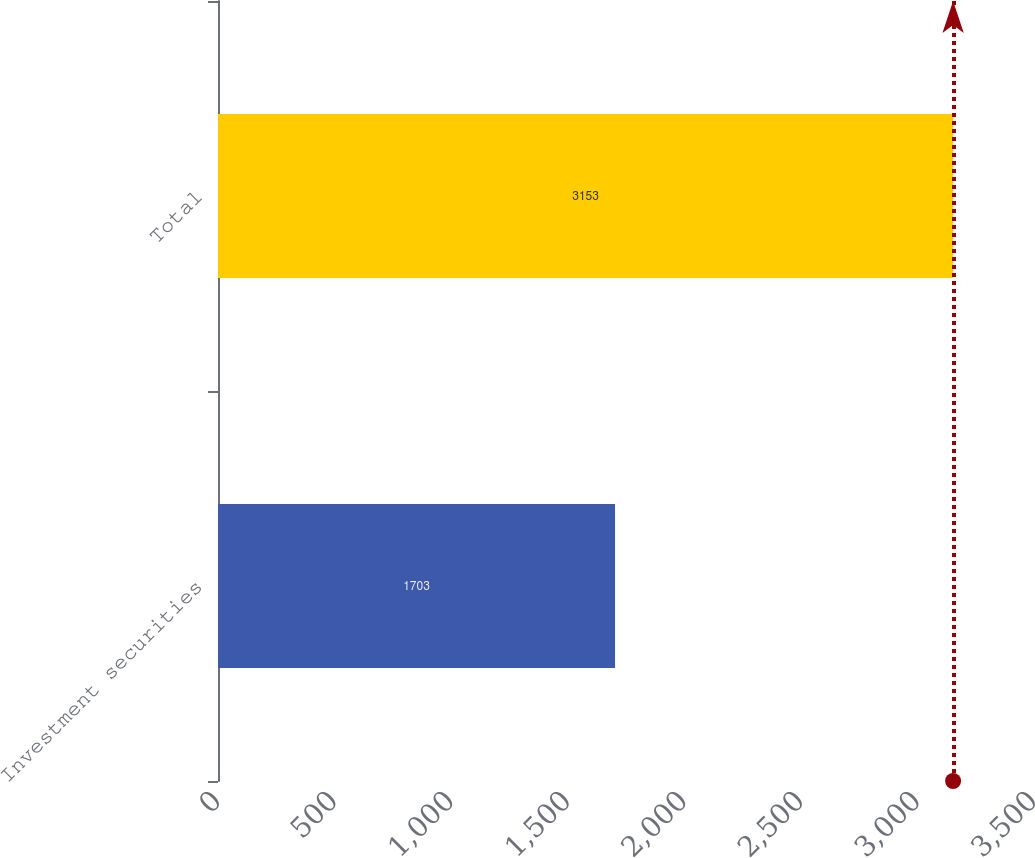Convert chart. <chart><loc_0><loc_0><loc_500><loc_500><bar_chart><fcel>Investment securities<fcel>Total<nl><fcel>1703<fcel>3153<nl></chart> 